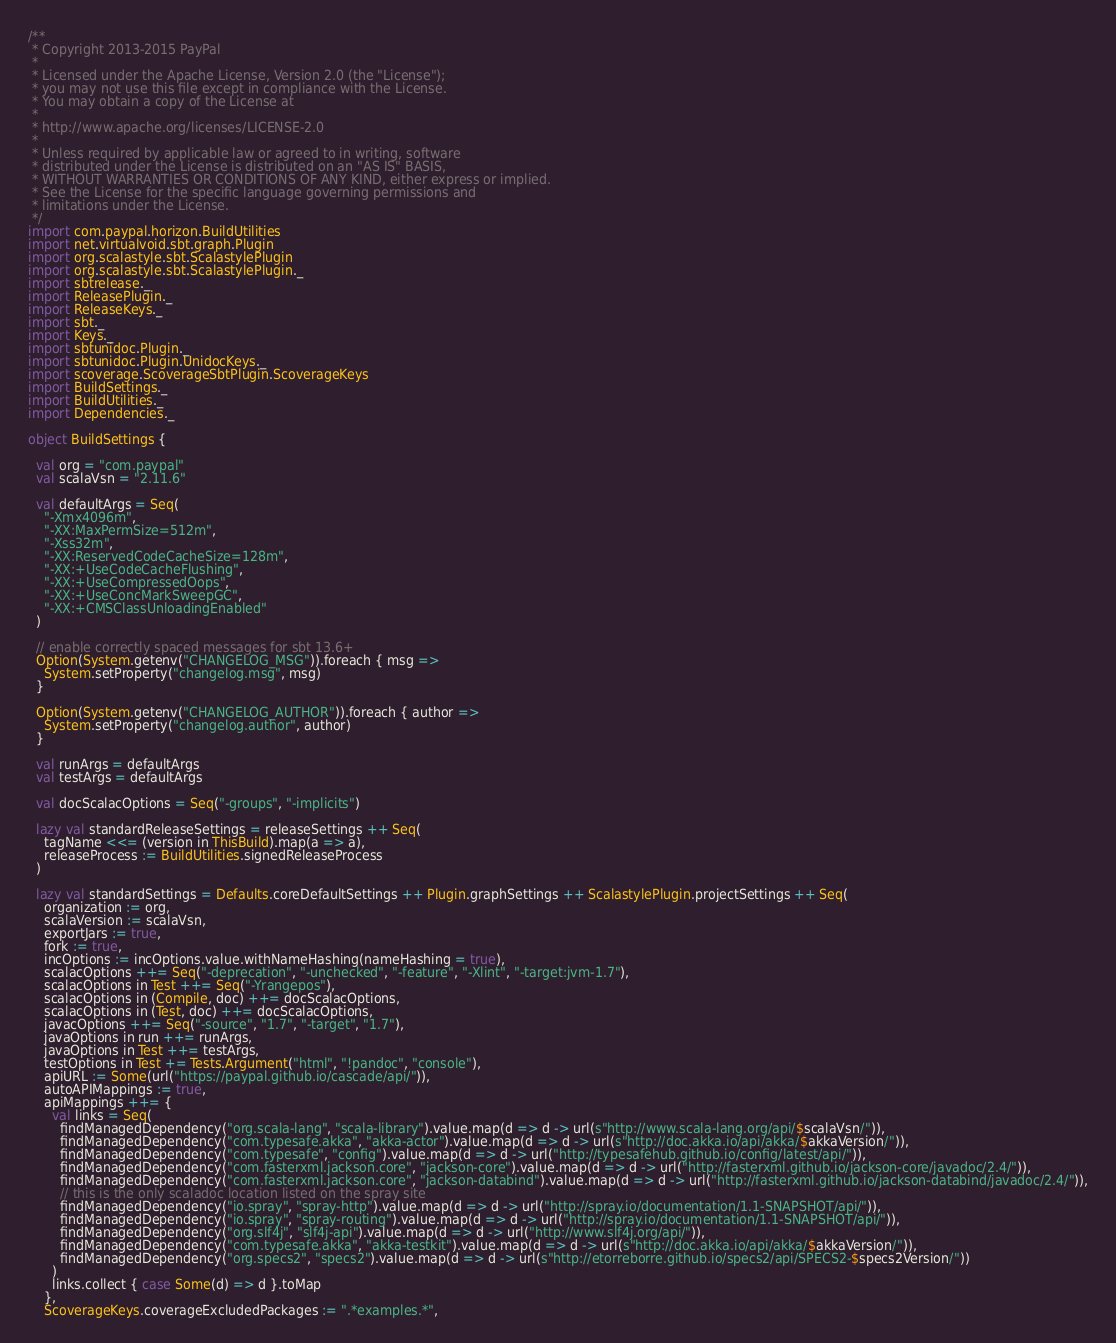Convert code to text. <code><loc_0><loc_0><loc_500><loc_500><_Scala_>/**
 * Copyright 2013-2015 PayPal
 *
 * Licensed under the Apache License, Version 2.0 (the "License");
 * you may not use this file except in compliance with the License.
 * You may obtain a copy of the License at
 *
 * http://www.apache.org/licenses/LICENSE-2.0
 *
 * Unless required by applicable law or agreed to in writing, software
 * distributed under the License is distributed on an "AS IS" BASIS,
 * WITHOUT WARRANTIES OR CONDITIONS OF ANY KIND, either express or implied.
 * See the License for the specific language governing permissions and
 * limitations under the License.
 */
import com.paypal.horizon.BuildUtilities
import net.virtualvoid.sbt.graph.Plugin
import org.scalastyle.sbt.ScalastylePlugin
import org.scalastyle.sbt.ScalastylePlugin._
import sbtrelease._
import ReleasePlugin._
import ReleaseKeys._
import sbt._
import Keys._
import sbtunidoc.Plugin._
import sbtunidoc.Plugin.UnidocKeys._
import scoverage.ScoverageSbtPlugin.ScoverageKeys
import BuildSettings._
import BuildUtilities._
import Dependencies._

object BuildSettings {

  val org = "com.paypal"
  val scalaVsn = "2.11.6"

  val defaultArgs = Seq(
    "-Xmx4096m",
    "-XX:MaxPermSize=512m",
    "-Xss32m",
    "-XX:ReservedCodeCacheSize=128m",
    "-XX:+UseCodeCacheFlushing",
    "-XX:+UseCompressedOops",
    "-XX:+UseConcMarkSweepGC",
    "-XX:+CMSClassUnloadingEnabled"
  )

  // enable correctly spaced messages for sbt 13.6+
  Option(System.getenv("CHANGELOG_MSG")).foreach { msg =>
    System.setProperty("changelog.msg", msg)
  }

  Option(System.getenv("CHANGELOG_AUTHOR")).foreach { author =>
    System.setProperty("changelog.author", author)
  }

  val runArgs = defaultArgs
  val testArgs = defaultArgs

  val docScalacOptions = Seq("-groups", "-implicits")

  lazy val standardReleaseSettings = releaseSettings ++ Seq(
    tagName <<= (version in ThisBuild).map(a => a),
    releaseProcess := BuildUtilities.signedReleaseProcess
  )

  lazy val standardSettings = Defaults.coreDefaultSettings ++ Plugin.graphSettings ++ ScalastylePlugin.projectSettings ++ Seq(
    organization := org,
    scalaVersion := scalaVsn,
    exportJars := true,
    fork := true,
    incOptions := incOptions.value.withNameHashing(nameHashing = true),
    scalacOptions ++= Seq("-deprecation", "-unchecked", "-feature", "-Xlint", "-target:jvm-1.7"),
    scalacOptions in Test ++= Seq("-Yrangepos"),
    scalacOptions in (Compile, doc) ++= docScalacOptions,
    scalacOptions in (Test, doc) ++= docScalacOptions,
    javacOptions ++= Seq("-source", "1.7", "-target", "1.7"),
    javaOptions in run ++= runArgs,
    javaOptions in Test ++= testArgs,
    testOptions in Test += Tests.Argument("html", "!pandoc", "console"),
    apiURL := Some(url("https://paypal.github.io/cascade/api/")),
    autoAPIMappings := true,
    apiMappings ++= {
      val links = Seq(
        findManagedDependency("org.scala-lang", "scala-library").value.map(d => d -> url(s"http://www.scala-lang.org/api/$scalaVsn/")),
        findManagedDependency("com.typesafe.akka", "akka-actor").value.map(d => d -> url(s"http://doc.akka.io/api/akka/$akkaVersion/")),
        findManagedDependency("com.typesafe", "config").value.map(d => d -> url("http://typesafehub.github.io/config/latest/api/")),
        findManagedDependency("com.fasterxml.jackson.core", "jackson-core").value.map(d => d -> url("http://fasterxml.github.io/jackson-core/javadoc/2.4/")),
        findManagedDependency("com.fasterxml.jackson.core", "jackson-databind").value.map(d => d -> url("http://fasterxml.github.io/jackson-databind/javadoc/2.4/")),
        // this is the only scaladoc location listed on the spray site
        findManagedDependency("io.spray", "spray-http").value.map(d => d -> url("http://spray.io/documentation/1.1-SNAPSHOT/api/")),
        findManagedDependency("io.spray", "spray-routing").value.map(d => d -> url("http://spray.io/documentation/1.1-SNAPSHOT/api/")),
        findManagedDependency("org.slf4j", "slf4j-api").value.map(d => d -> url("http://www.slf4j.org/api/")),
        findManagedDependency("com.typesafe.akka", "akka-testkit").value.map(d => d -> url(s"http://doc.akka.io/api/akka/$akkaVersion/")),
        findManagedDependency("org.specs2", "specs2").value.map(d => d -> url(s"http://etorreborre.github.io/specs2/api/SPECS2-$specs2Version/"))
      )
      links.collect { case Some(d) => d }.toMap
    },
    ScoverageKeys.coverageExcludedPackages := ".*examples.*",</code> 